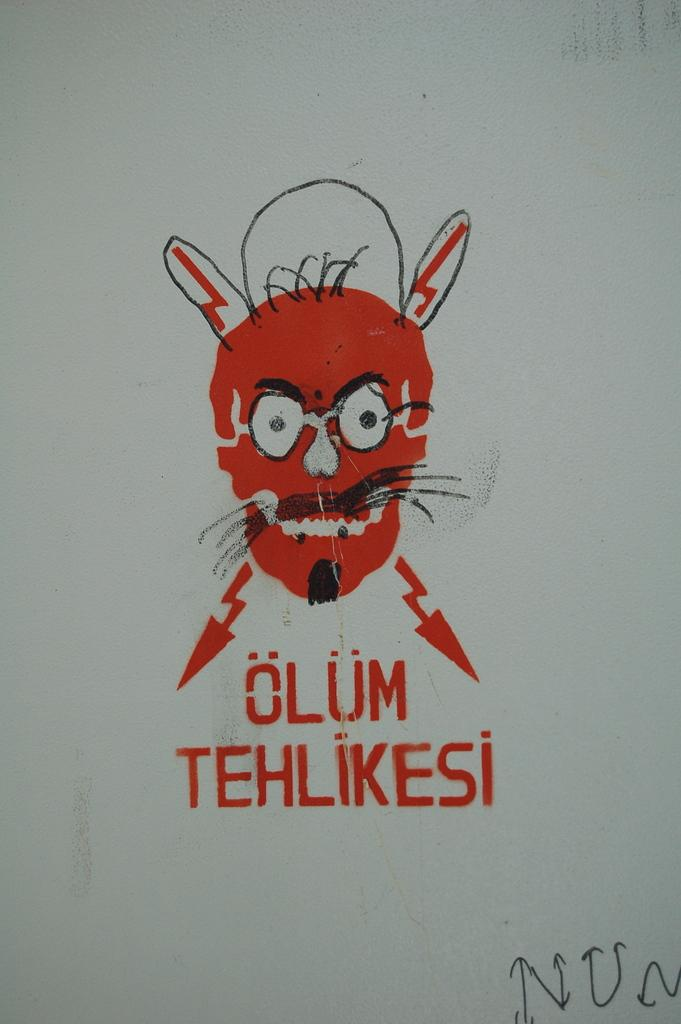What is the main subject in the center of the image? There is a painting on the wall in the center of the image. Can you describe the painting? Unfortunately, the facts provided do not give any details about the painting. What else can be seen in the image besides the painting? There is some text in the image. What month is depicted in the painting? There is no information about the painting's content, so it is impossible to determine if a month is depicted. How does the text in the image express anger? There is no information about the text's content, so it is impossible to determine if it expresses anger. 